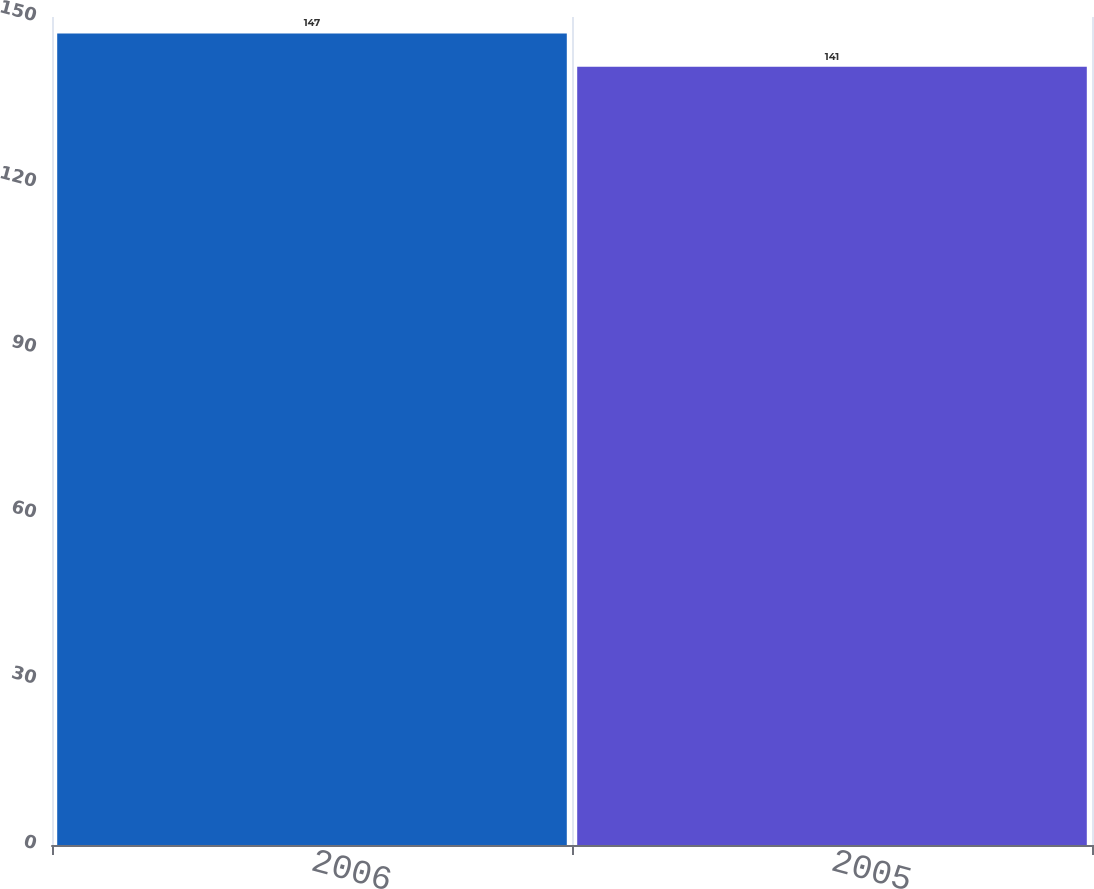<chart> <loc_0><loc_0><loc_500><loc_500><bar_chart><fcel>2006<fcel>2005<nl><fcel>147<fcel>141<nl></chart> 